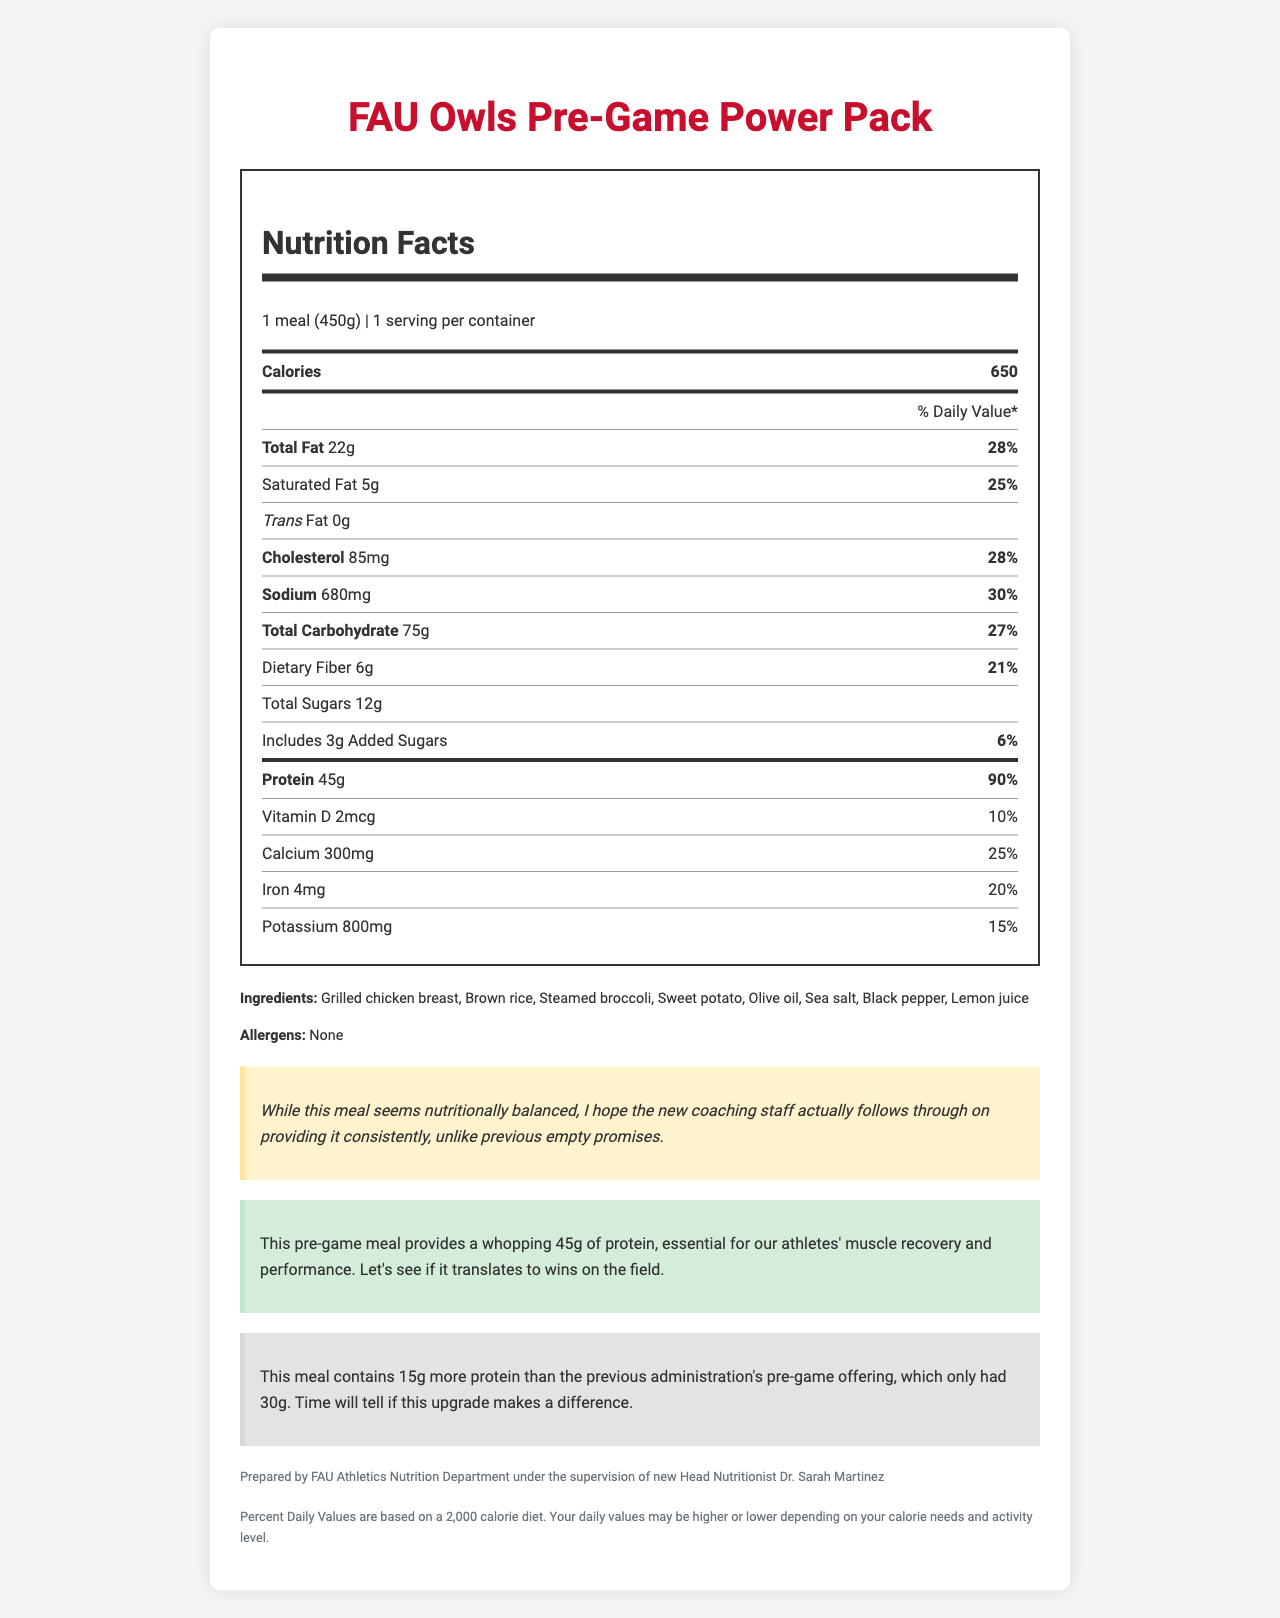what is the serving size of the FAU Owls Pre-Game Power Pack? The serving size is explicitly mentioned as "1 meal (450g)" in the document.
Answer: 1 meal (450g) how much protein does the FAU Owls Pre-Game Power Pack contain? The document displays the protein content as "45g" under the protein section in the Nutrition Facts table.
Answer: 45g what is the daily value percentage of protein in the FAU Owls Pre-Game Power Pack? According to the nutrition label, the daily value percentage for protein is listed as "90%."
Answer: 90% does the FAU Owls Pre-Game Power Pack contain any trans fat? The document specifies "0g" for trans fat in the Nutrition Facts table.
Answer: No which ingredient is not included in the FAU Owls Pre-Game Power Pack? A. Grilled chicken breast B. Olive oil C. Sweet potato D. Almonds The document lists the ingredients as "Grilled chicken breast, Brown rice, Steamed broccoli, Sweet potato, Olive oil, Sea salt, Black pepper, Lemon juice." Almonds are not included.
Answer: D what is the percentage of total carbohydrates' daily value? The daily value percentage for total carbohydrates is "27%" as mentioned in the Nutrition Facts table.
Answer: 27% what is the main source of protein in the FAU Owls Pre-Game Power Pack? Among the listed ingredients, "Grilled chicken breast" is the most likely main source of protein.
Answer: Grilled chicken breast what should I do if I have a food allergy? The document mentions that there are no allergens, but it does not provide specific steps for managing food allergies.
Answer: Not enough information does the pre-game meal contain added sugars? The document shows that the pre-game meal contains "3g" of added sugars in the Nutrition Facts table.
Answer: Yes how does the FAU Owls Pre-Game Power Pack compare to the previous administration’s pre-game offering in terms of protein? The comparison section in the document states that this meal contains 45g of protein compared to 30g in the previous administration's offering, indicating a 15g increase.
Answer: The FAU Owls Pre-Game Power Pack contains 15g more protein than the previous offering, which had 30g. who supervised the preparation of FAU Owls Pre-Game Power Pack? The document's source section notes that it was prepared under the supervision of "new Head Nutritionist Dr. Sarah Martinez."
Answer: Dr. Sarah Martinez is there any sodium in the FAU Owls Pre-Game Power Pack? The Nutrition Facts table lists "680mg" of sodium, indicating the presence of sodium in the meal.
Answer: Yes summarize the key information presented in the document. The document provides comprehensive nutrition information about the FAU Owls Pre-Game Power Pack, highlighting its high protein content and comparing it to previous meals. It also details the ingredients and preparation supervision while expressing a hope for consistent provision.
Answer: The FAU Owls Pre-Game Power Pack is a meal designed for athletes, with a serving size of 450g, containing 650 calories, 22g of total fat, 75g of carbohydrates, and 45g of protein. The ingredients include grilled chicken breast, brown rice, steamed broccoli, and sweet potato, with no allergens listed. The document highlights the significant protein content and compares it favorably to previous meals. It was prepared under the new head nutritionist Dr. Sarah Martinez, with a note expressing skepticism about consistency in provision. are there any allergens in the FAU Owls Pre-Game Power Pack? The document explicitly states that there are no allergens in the meal.
Answer: No 